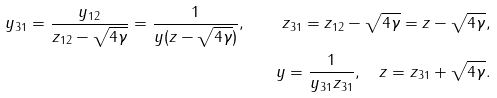Convert formula to latex. <formula><loc_0><loc_0><loc_500><loc_500>y _ { 3 1 } = \frac { y _ { 1 2 } } { z _ { 1 2 } - \sqrt { 4 \gamma } } = \frac { 1 } { y ( z - \sqrt { 4 \gamma } ) } , \quad z _ { 3 1 } = z _ { 1 2 } - \sqrt { 4 \gamma } = z - \sqrt { 4 \gamma } , \\ y = \frac { 1 } { y _ { 3 1 } z _ { 3 1 } } , \quad z = z _ { 3 1 } + \sqrt { 4 \gamma } .</formula> 